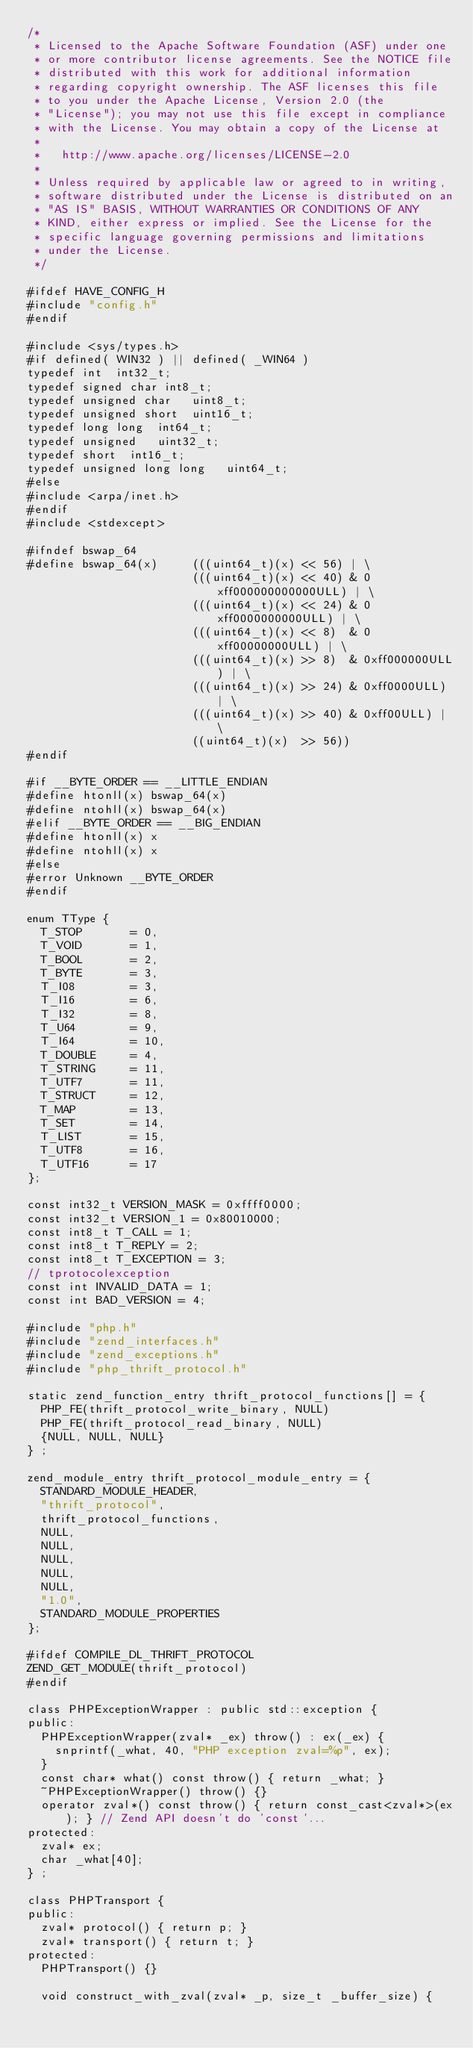<code> <loc_0><loc_0><loc_500><loc_500><_C++_>/*
 * Licensed to the Apache Software Foundation (ASF) under one
 * or more contributor license agreements. See the NOTICE file
 * distributed with this work for additional information
 * regarding copyright ownership. The ASF licenses this file
 * to you under the Apache License, Version 2.0 (the
 * "License"); you may not use this file except in compliance
 * with the License. You may obtain a copy of the License at
 *
 *   http://www.apache.org/licenses/LICENSE-2.0
 *
 * Unless required by applicable law or agreed to in writing,
 * software distributed under the License is distributed on an
 * "AS IS" BASIS, WITHOUT WARRANTIES OR CONDITIONS OF ANY
 * KIND, either express or implied. See the License for the
 * specific language governing permissions and limitations
 * under the License.
 */

#ifdef HAVE_CONFIG_H
#include "config.h"
#endif

#include <sys/types.h>
#if defined( WIN32 ) || defined( _WIN64 )
typedef int  int32_t; 
typedef signed char int8_t;
typedef unsigned char   uint8_t;
typedef unsigned short  uint16_t;
typedef long long  int64_t;
typedef unsigned   uint32_t; 
typedef short  int16_t; 
typedef unsigned long long   uint64_t;
#else
#include <arpa/inet.h> 
#endif
#include <stdexcept>

#ifndef bswap_64
#define	bswap_64(x)     (((uint64_t)(x) << 56) | \
                        (((uint64_t)(x) << 40) & 0xff000000000000ULL) | \
                        (((uint64_t)(x) << 24) & 0xff0000000000ULL) | \
                        (((uint64_t)(x) << 8)  & 0xff00000000ULL) | \
                        (((uint64_t)(x) >> 8)  & 0xff000000ULL) | \
                        (((uint64_t)(x) >> 24) & 0xff0000ULL) | \
                        (((uint64_t)(x) >> 40) & 0xff00ULL) | \
                        ((uint64_t)(x)  >> 56))
#endif

#if __BYTE_ORDER == __LITTLE_ENDIAN
#define htonll(x) bswap_64(x)
#define ntohll(x) bswap_64(x)
#elif __BYTE_ORDER == __BIG_ENDIAN
#define htonll(x) x
#define ntohll(x) x
#else
#error Unknown __BYTE_ORDER
#endif

enum TType {
  T_STOP       = 0,
  T_VOID       = 1,
  T_BOOL       = 2,
  T_BYTE       = 3,
  T_I08        = 3,
  T_I16        = 6,
  T_I32        = 8,
  T_U64        = 9,
  T_I64        = 10,
  T_DOUBLE     = 4,
  T_STRING     = 11,
  T_UTF7       = 11,
  T_STRUCT     = 12,
  T_MAP        = 13,
  T_SET        = 14,
  T_LIST       = 15,
  T_UTF8       = 16,
  T_UTF16      = 17
};

const int32_t VERSION_MASK = 0xffff0000;
const int32_t VERSION_1 = 0x80010000;
const int8_t T_CALL = 1;
const int8_t T_REPLY = 2;
const int8_t T_EXCEPTION = 3;
// tprotocolexception
const int INVALID_DATA = 1;
const int BAD_VERSION = 4;

#include "php.h"
#include "zend_interfaces.h"
#include "zend_exceptions.h"
#include "php_thrift_protocol.h"

static zend_function_entry thrift_protocol_functions[] = {
  PHP_FE(thrift_protocol_write_binary, NULL)
  PHP_FE(thrift_protocol_read_binary, NULL)
  {NULL, NULL, NULL}
} ;

zend_module_entry thrift_protocol_module_entry = {
  STANDARD_MODULE_HEADER,
  "thrift_protocol",
  thrift_protocol_functions,
  NULL,
  NULL,
  NULL,
  NULL,
  NULL,
  "1.0",
  STANDARD_MODULE_PROPERTIES
};

#ifdef COMPILE_DL_THRIFT_PROTOCOL
ZEND_GET_MODULE(thrift_protocol)
#endif

class PHPExceptionWrapper : public std::exception {
public:
  PHPExceptionWrapper(zval* _ex) throw() : ex(_ex) {
    snprintf(_what, 40, "PHP exception zval=%p", ex);
  }
  const char* what() const throw() { return _what; }
  ~PHPExceptionWrapper() throw() {}
  operator zval*() const throw() { return const_cast<zval*>(ex); } // Zend API doesn't do 'const'...
protected:
  zval* ex;
  char _what[40];
} ;

class PHPTransport {
public:
  zval* protocol() { return p; }
  zval* transport() { return t; }
protected:
  PHPTransport() {}

  void construct_with_zval(zval* _p, size_t _buffer_size) {</code> 